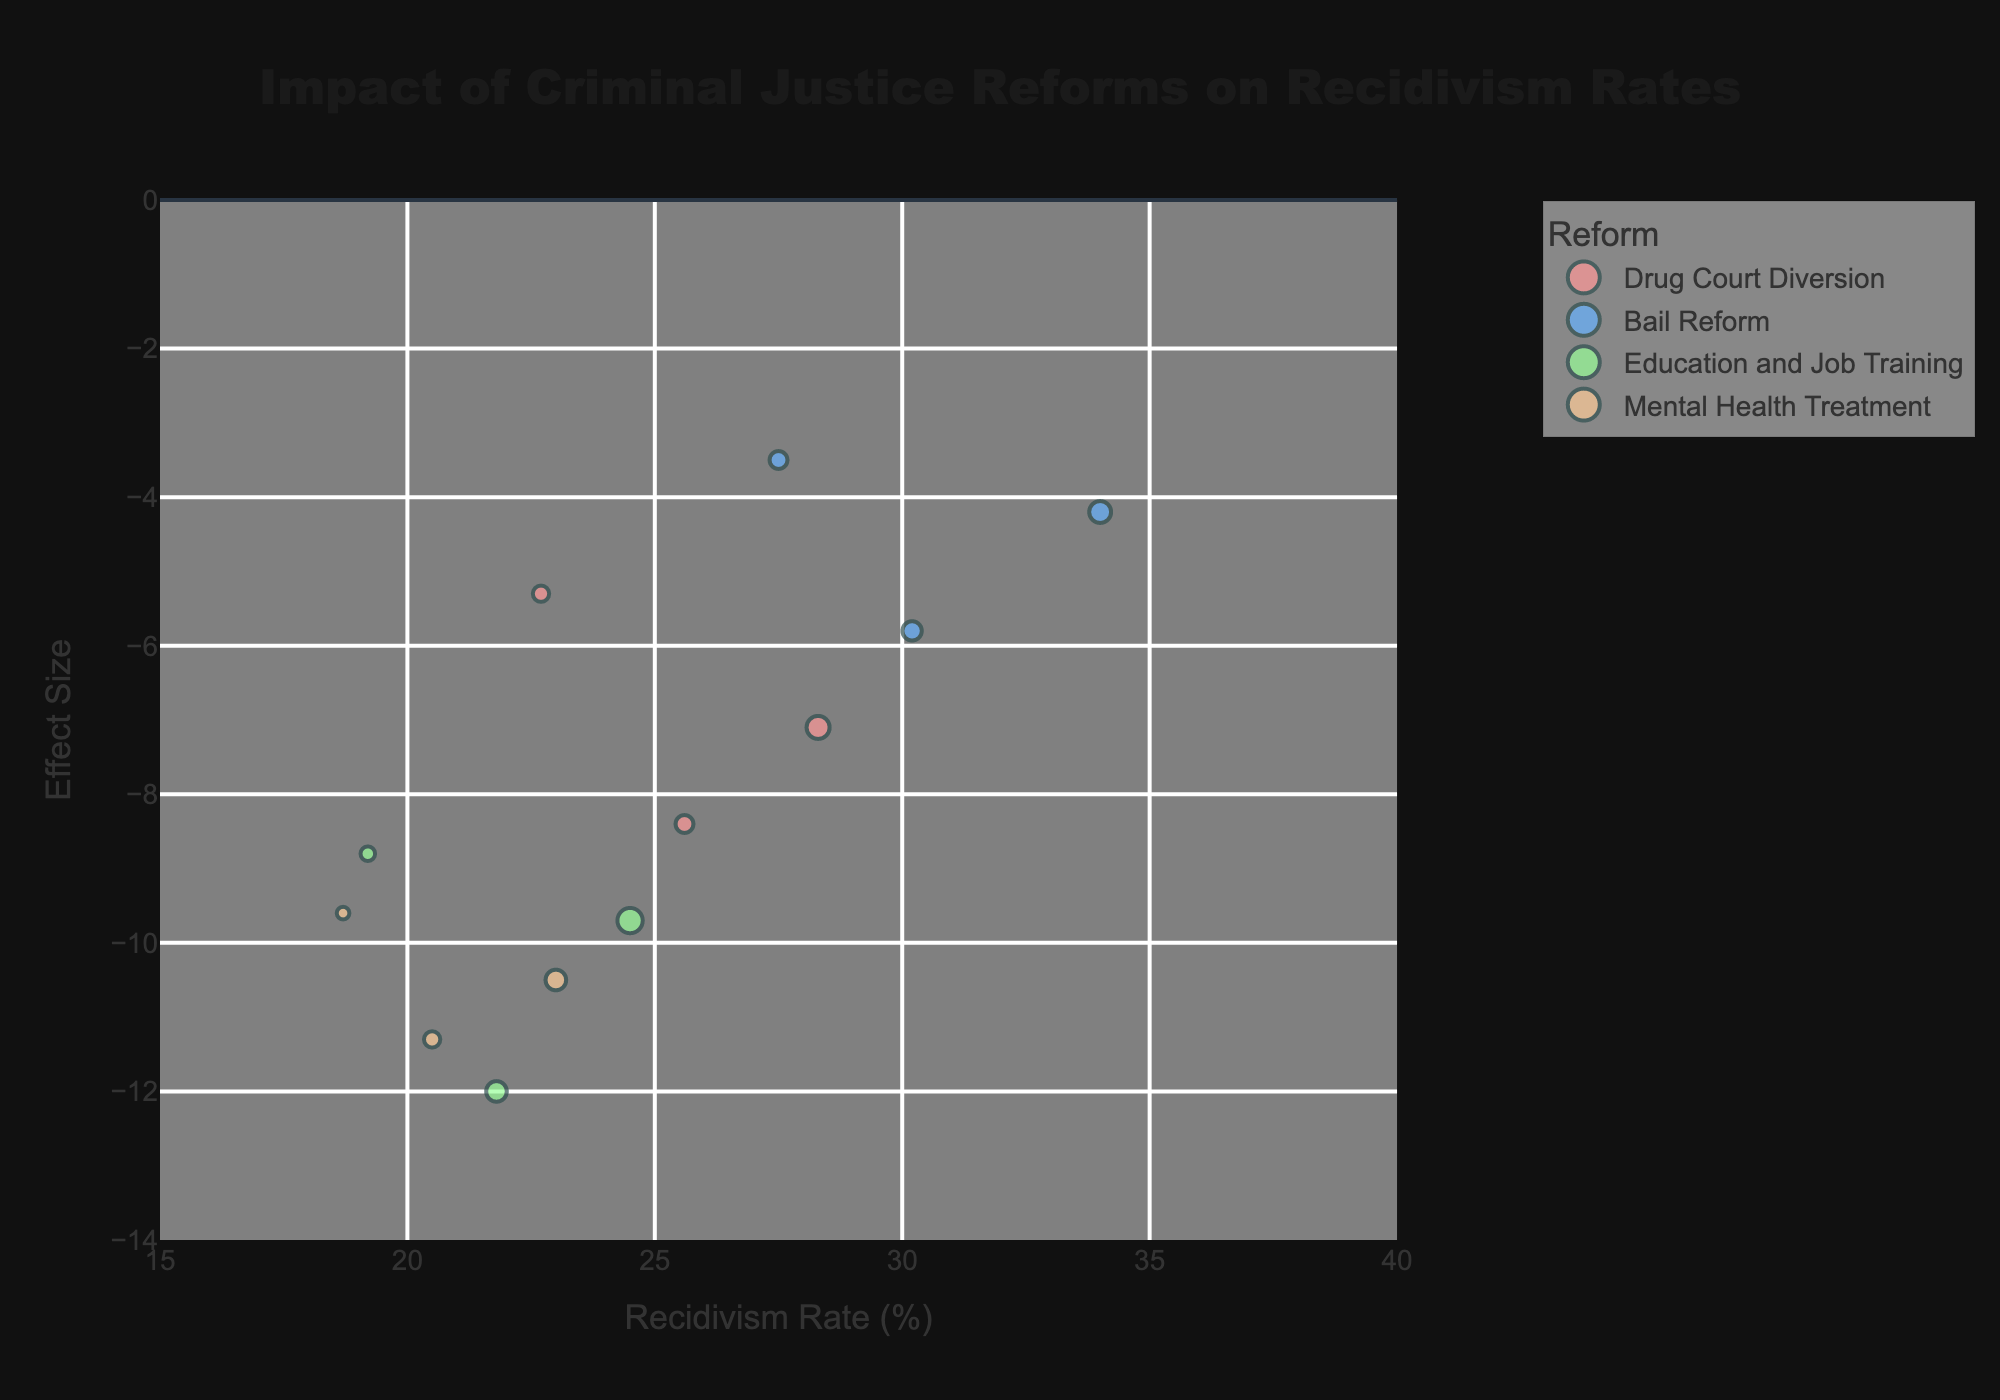What's the title of the figure? The title of the figure is displayed prominently at the top. It reads: "Impact of Criminal Justice Reforms on Recidivism Rates".
Answer: Impact of Criminal Justice Reforms on Recidivism Rates What does the x-axis represent? The x-axis is labeled, and it represents the "Recidivism Rate (%)".
Answer: Recidivism Rate (%) Which reform shows the largest reduction in recidivism rate for seniors (41+)? By identifying the bubble representing "Seniors (41+)" for each reform and checking their effect sizes, "Education and Job Training" shows the largest reduction, with an effect size of -8.8.
Answer: Education and Job Training How do the recidivism rates for young adults (18-25) compare between Drug Court Diversion and Bail Reform? Locate the bubbles for young adults under both reforms: "Drug Court Diversion" has a recidivism rate of 25.6%, while "Bail Reform" has a recidivism rate of 30.2%.
Answer: Drug Court Diversion: 25.6%, Bail Reform: 30.2% Which demographic has the smallest initial population under Mental Health Treatment? Find the bubbles for "Mental Health Treatment" and identify the demographic with the smallest size bubble, which is "Seniors (41+)" with an initial population of 150.
Answer: Seniors (41+) What is the effect size range for all the reforms on young adults (18-25)? The effect sizes for young adults vary from -12.0 (Education and Job Training) to -5.8 (Bail Reform).
Answer: -12.0 to -5.8 Which reform has no overlap in recidivism rates for any demographics? By tracing the recidivism rates and seeing if any bubbles overlap on the x-axis, "Education and Job Training" has distinct rates for all demographics: 21.8%, 24.5%, and 19.2%.
Answer: Education and Job Training How does the effect size of Bail Reform for adults (26-40) compare to the effect size of Mental Health Treatment for the same demographic? Comparing the effect sizes, Bail Reform has an effect size of -4.2, whereas Mental Health Treatment has an effect size of -10.5. Thus, Mental Health Treatment has a greater reduction.
Answer: Bail Reform: -4.2, Mental Health Treatment: -10.5 What is the average initial population size across all demographics for Drug Court Diversion? The initial populations for Drug Court Diversion are 300 (young adults), 500 (adults), and 250 (seniors). The average is calculated as (300 + 500 + 250) / 3.
Answer: 350 Which demographic under Education and Job Training has the highest recidivism rate? The recidivism rates for Education and Job Training are 21.8% (young adults), 24.5% (adults), and 19.2% (seniors). Adults (26-40) have the highest rate.
Answer: Adults (26-40) 